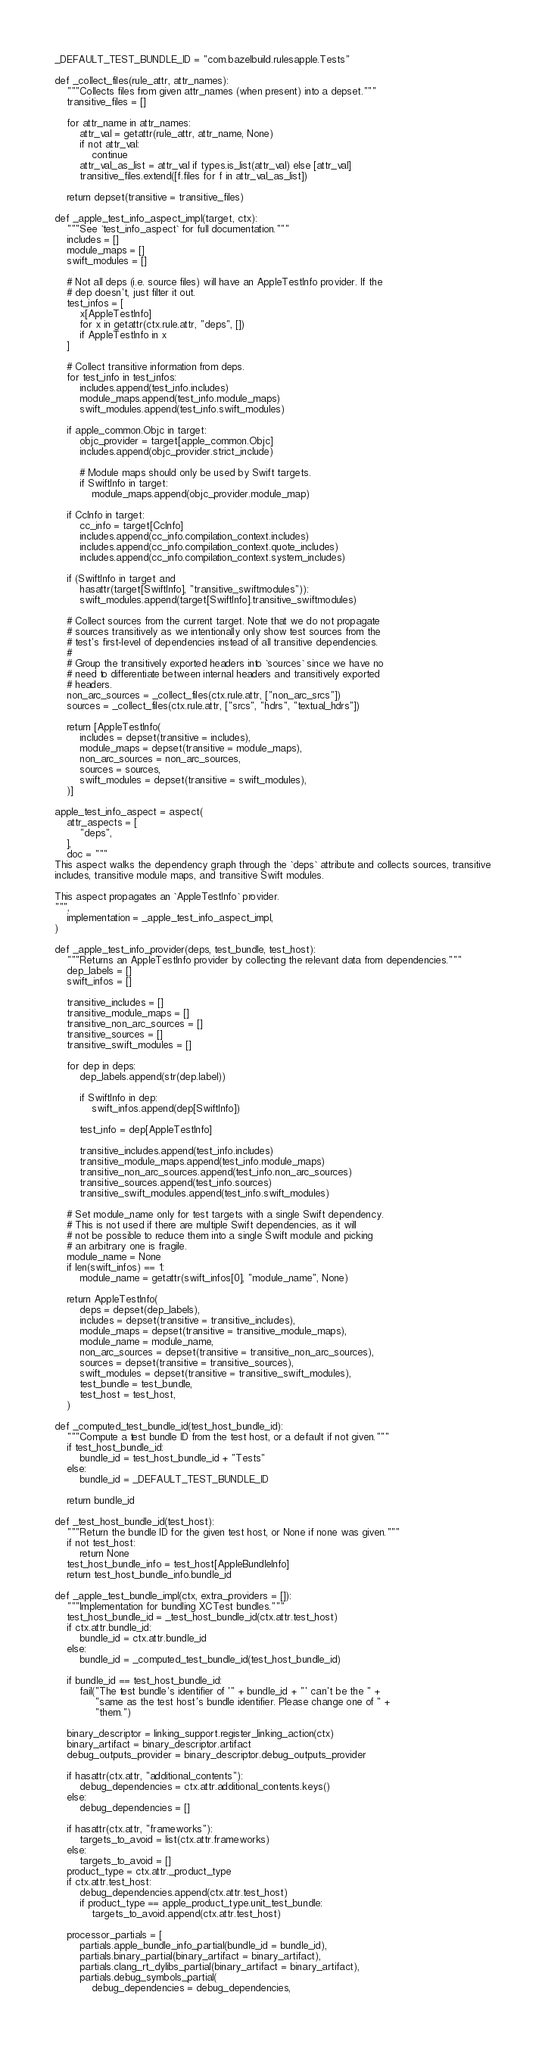Convert code to text. <code><loc_0><loc_0><loc_500><loc_500><_Python_>_DEFAULT_TEST_BUNDLE_ID = "com.bazelbuild.rulesapple.Tests"

def _collect_files(rule_attr, attr_names):
    """Collects files from given attr_names (when present) into a depset."""
    transitive_files = []

    for attr_name in attr_names:
        attr_val = getattr(rule_attr, attr_name, None)
        if not attr_val:
            continue
        attr_val_as_list = attr_val if types.is_list(attr_val) else [attr_val]
        transitive_files.extend([f.files for f in attr_val_as_list])

    return depset(transitive = transitive_files)

def _apple_test_info_aspect_impl(target, ctx):
    """See `test_info_aspect` for full documentation."""
    includes = []
    module_maps = []
    swift_modules = []

    # Not all deps (i.e. source files) will have an AppleTestInfo provider. If the
    # dep doesn't, just filter it out.
    test_infos = [
        x[AppleTestInfo]
        for x in getattr(ctx.rule.attr, "deps", [])
        if AppleTestInfo in x
    ]

    # Collect transitive information from deps.
    for test_info in test_infos:
        includes.append(test_info.includes)
        module_maps.append(test_info.module_maps)
        swift_modules.append(test_info.swift_modules)

    if apple_common.Objc in target:
        objc_provider = target[apple_common.Objc]
        includes.append(objc_provider.strict_include)

        # Module maps should only be used by Swift targets.
        if SwiftInfo in target:
            module_maps.append(objc_provider.module_map)

    if CcInfo in target:
        cc_info = target[CcInfo]
        includes.append(cc_info.compilation_context.includes)
        includes.append(cc_info.compilation_context.quote_includes)
        includes.append(cc_info.compilation_context.system_includes)

    if (SwiftInfo in target and
        hasattr(target[SwiftInfo], "transitive_swiftmodules")):
        swift_modules.append(target[SwiftInfo].transitive_swiftmodules)

    # Collect sources from the current target. Note that we do not propagate
    # sources transitively as we intentionally only show test sources from the
    # test's first-level of dependencies instead of all transitive dependencies.
    #
    # Group the transitively exported headers into `sources` since we have no
    # need to differentiate between internal headers and transitively exported
    # headers.
    non_arc_sources = _collect_files(ctx.rule.attr, ["non_arc_srcs"])
    sources = _collect_files(ctx.rule.attr, ["srcs", "hdrs", "textual_hdrs"])

    return [AppleTestInfo(
        includes = depset(transitive = includes),
        module_maps = depset(transitive = module_maps),
        non_arc_sources = non_arc_sources,
        sources = sources,
        swift_modules = depset(transitive = swift_modules),
    )]

apple_test_info_aspect = aspect(
    attr_aspects = [
        "deps",
    ],
    doc = """
This aspect walks the dependency graph through the `deps` attribute and collects sources, transitive
includes, transitive module maps, and transitive Swift modules.

This aspect propagates an `AppleTestInfo` provider.
""",
    implementation = _apple_test_info_aspect_impl,
)

def _apple_test_info_provider(deps, test_bundle, test_host):
    """Returns an AppleTestInfo provider by collecting the relevant data from dependencies."""
    dep_labels = []
    swift_infos = []

    transitive_includes = []
    transitive_module_maps = []
    transitive_non_arc_sources = []
    transitive_sources = []
    transitive_swift_modules = []

    for dep in deps:
        dep_labels.append(str(dep.label))

        if SwiftInfo in dep:
            swift_infos.append(dep[SwiftInfo])

        test_info = dep[AppleTestInfo]

        transitive_includes.append(test_info.includes)
        transitive_module_maps.append(test_info.module_maps)
        transitive_non_arc_sources.append(test_info.non_arc_sources)
        transitive_sources.append(test_info.sources)
        transitive_swift_modules.append(test_info.swift_modules)

    # Set module_name only for test targets with a single Swift dependency.
    # This is not used if there are multiple Swift dependencies, as it will
    # not be possible to reduce them into a single Swift module and picking
    # an arbitrary one is fragile.
    module_name = None
    if len(swift_infos) == 1:
        module_name = getattr(swift_infos[0], "module_name", None)

    return AppleTestInfo(
        deps = depset(dep_labels),
        includes = depset(transitive = transitive_includes),
        module_maps = depset(transitive = transitive_module_maps),
        module_name = module_name,
        non_arc_sources = depset(transitive = transitive_non_arc_sources),
        sources = depset(transitive = transitive_sources),
        swift_modules = depset(transitive = transitive_swift_modules),
        test_bundle = test_bundle,
        test_host = test_host,
    )

def _computed_test_bundle_id(test_host_bundle_id):
    """Compute a test bundle ID from the test host, or a default if not given."""
    if test_host_bundle_id:
        bundle_id = test_host_bundle_id + "Tests"
    else:
        bundle_id = _DEFAULT_TEST_BUNDLE_ID

    return bundle_id

def _test_host_bundle_id(test_host):
    """Return the bundle ID for the given test host, or None if none was given."""
    if not test_host:
        return None
    test_host_bundle_info = test_host[AppleBundleInfo]
    return test_host_bundle_info.bundle_id

def _apple_test_bundle_impl(ctx, extra_providers = []):
    """Implementation for bundling XCTest bundles."""
    test_host_bundle_id = _test_host_bundle_id(ctx.attr.test_host)
    if ctx.attr.bundle_id:
        bundle_id = ctx.attr.bundle_id
    else:
        bundle_id = _computed_test_bundle_id(test_host_bundle_id)

    if bundle_id == test_host_bundle_id:
        fail("The test bundle's identifier of '" + bundle_id + "' can't be the " +
             "same as the test host's bundle identifier. Please change one of " +
             "them.")

    binary_descriptor = linking_support.register_linking_action(ctx)
    binary_artifact = binary_descriptor.artifact
    debug_outputs_provider = binary_descriptor.debug_outputs_provider

    if hasattr(ctx.attr, "additional_contents"):
        debug_dependencies = ctx.attr.additional_contents.keys()
    else:
        debug_dependencies = []

    if hasattr(ctx.attr, "frameworks"):
        targets_to_avoid = list(ctx.attr.frameworks)
    else:
        targets_to_avoid = []
    product_type = ctx.attr._product_type
    if ctx.attr.test_host:
        debug_dependencies.append(ctx.attr.test_host)
        if product_type == apple_product_type.unit_test_bundle:
            targets_to_avoid.append(ctx.attr.test_host)

    processor_partials = [
        partials.apple_bundle_info_partial(bundle_id = bundle_id),
        partials.binary_partial(binary_artifact = binary_artifact),
        partials.clang_rt_dylibs_partial(binary_artifact = binary_artifact),
        partials.debug_symbols_partial(
            debug_dependencies = debug_dependencies,</code> 